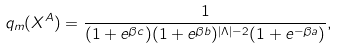Convert formula to latex. <formula><loc_0><loc_0><loc_500><loc_500>q _ { m } ( X ^ { A } ) = \frac { 1 } { ( 1 + e ^ { \beta c } ) ( 1 + e ^ { \beta b } ) ^ { | \Lambda | - 2 } ( 1 + e ^ { - \beta a } ) } ,</formula> 